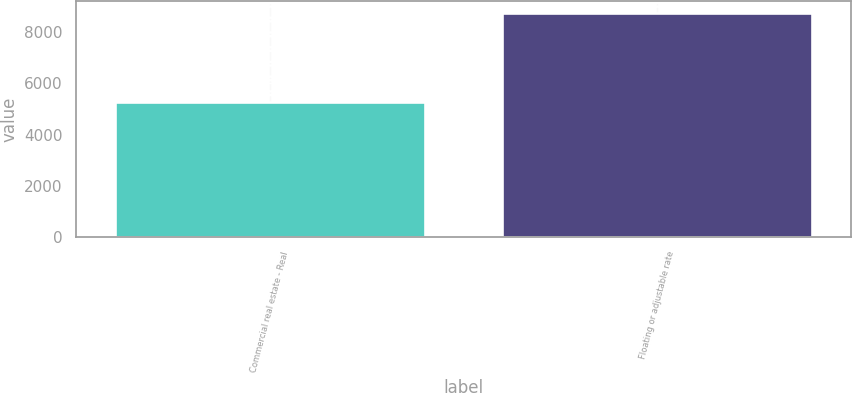Convert chart. <chart><loc_0><loc_0><loc_500><loc_500><bar_chart><fcel>Commercial real estate - Real<fcel>Floating or adjustable rate<nl><fcel>5281<fcel>8770<nl></chart> 